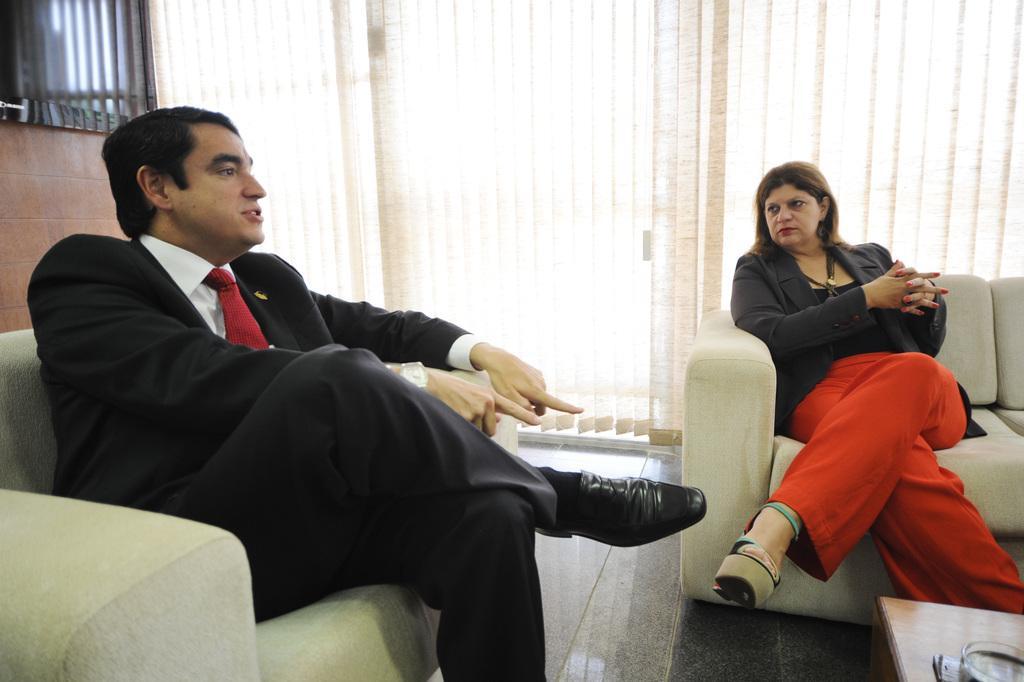Could you give a brief overview of what you see in this image? A man is sitting in sofa and speaking. And a woman beside him is listening to him. 